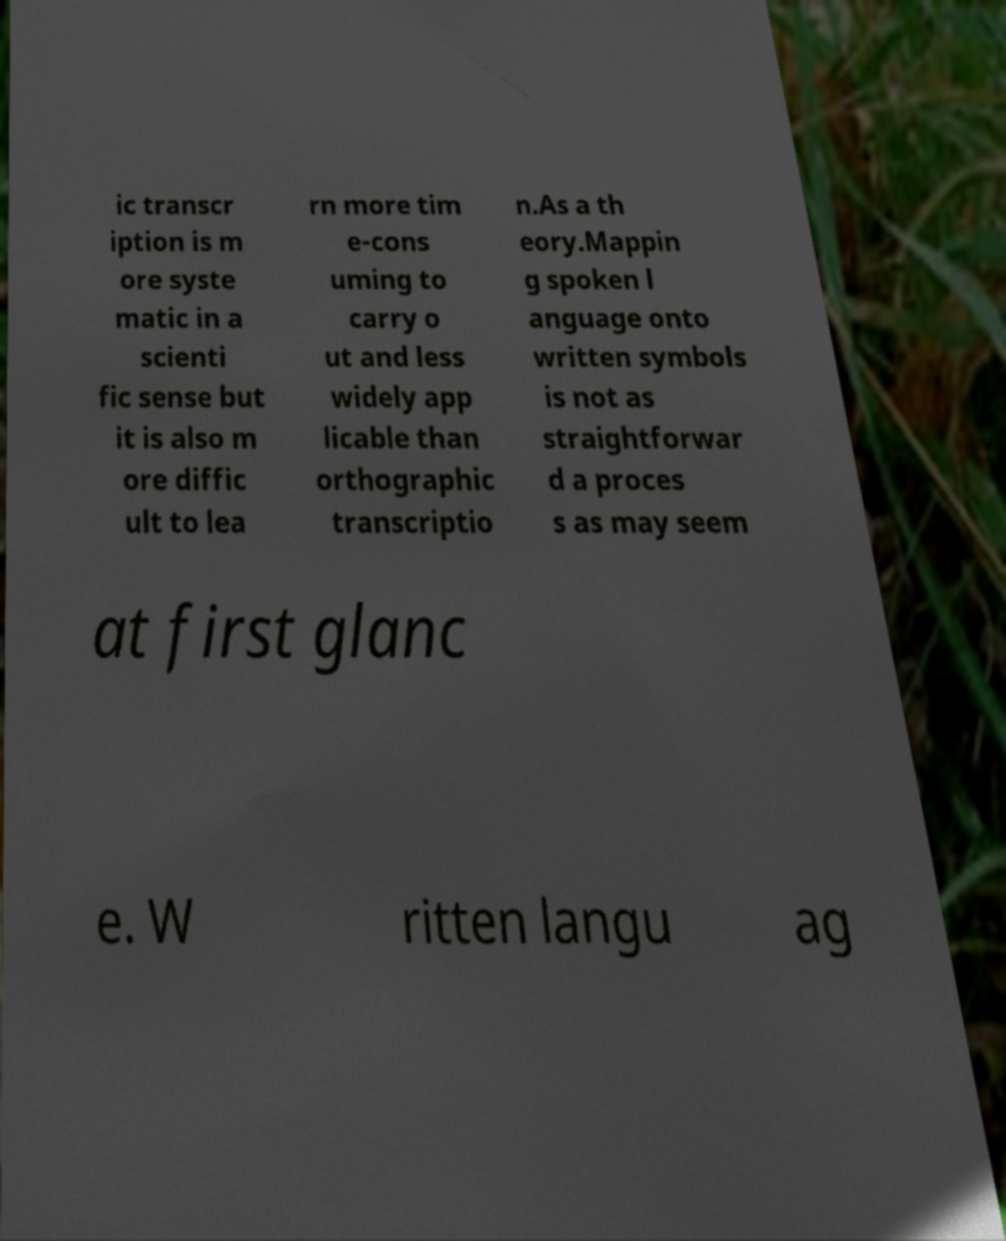What messages or text are displayed in this image? I need them in a readable, typed format. ic transcr iption is m ore syste matic in a scienti fic sense but it is also m ore diffic ult to lea rn more tim e-cons uming to carry o ut and less widely app licable than orthographic transcriptio n.As a th eory.Mappin g spoken l anguage onto written symbols is not as straightforwar d a proces s as may seem at first glanc e. W ritten langu ag 